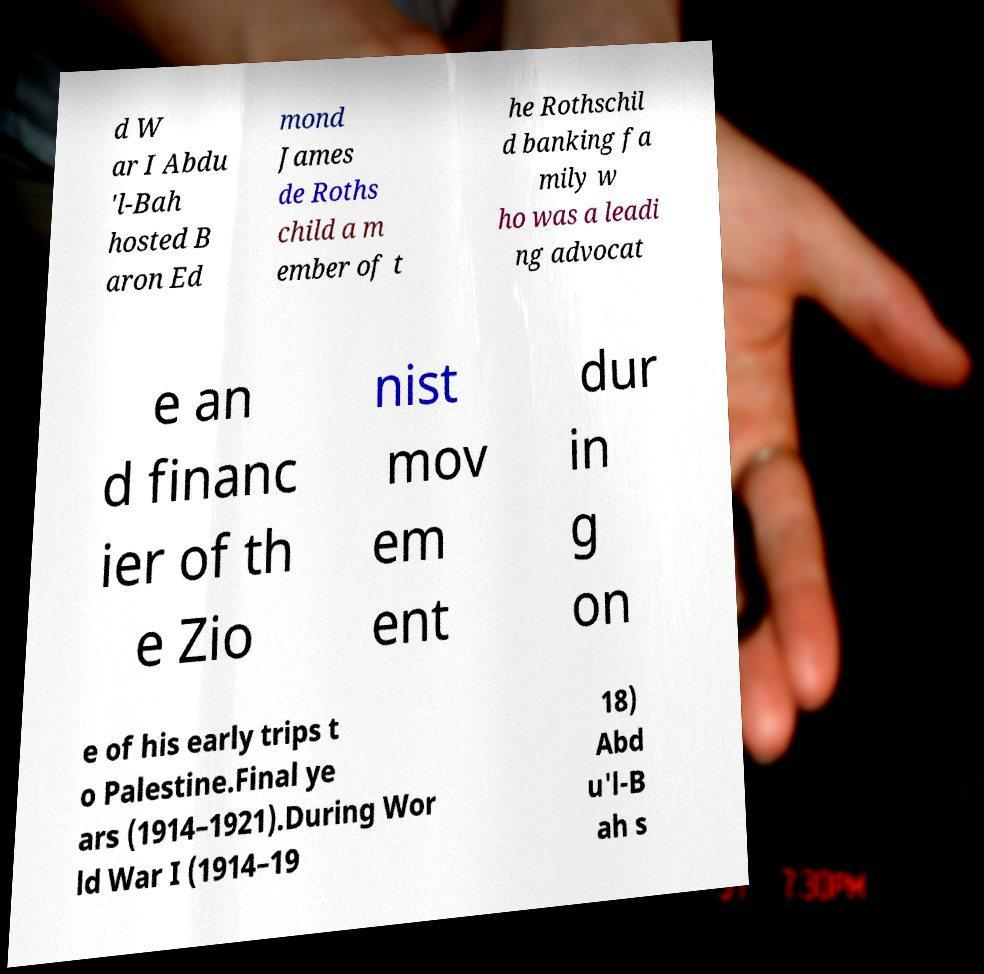Please read and relay the text visible in this image. What does it say? d W ar I Abdu 'l-Bah hosted B aron Ed mond James de Roths child a m ember of t he Rothschil d banking fa mily w ho was a leadi ng advocat e an d financ ier of th e Zio nist mov em ent dur in g on e of his early trips t o Palestine.Final ye ars (1914–1921).During Wor ld War I (1914–19 18) Abd u'l-B ah s 